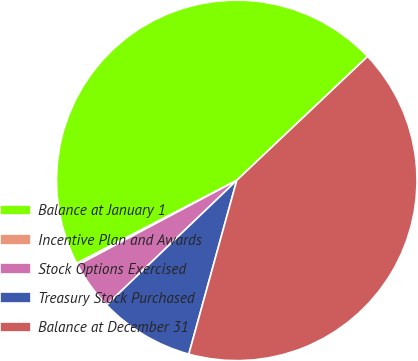<chart> <loc_0><loc_0><loc_500><loc_500><pie_chart><fcel>Balance at January 1<fcel>Incentive Plan and Awards<fcel>Stock Options Exercised<fcel>Treasury Stock Purchased<fcel>Balance at December 31<nl><fcel>45.54%<fcel>0.18%<fcel>4.37%<fcel>8.56%<fcel>41.35%<nl></chart> 